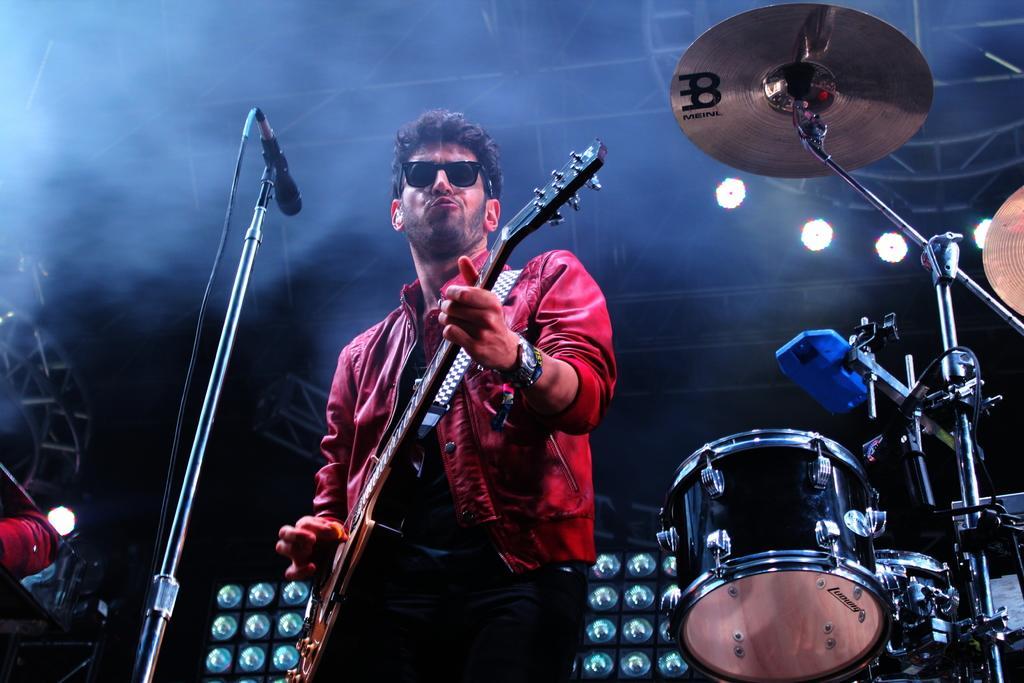Please provide a concise description of this image. In this Image I see a man who is wearing shades and holding a guitar and there is a mic over here. I can also see another musical instrument over here. In the background I see the lights. 